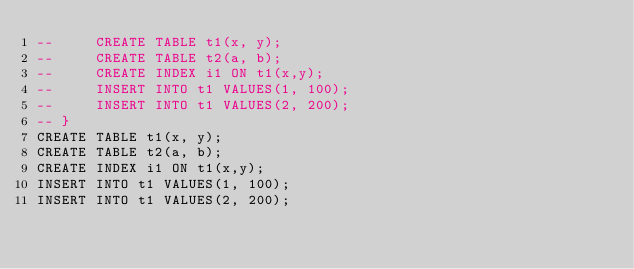<code> <loc_0><loc_0><loc_500><loc_500><_SQL_>--     CREATE TABLE t1(x, y);
--     CREATE TABLE t2(a, b);
--     CREATE INDEX i1 ON t1(x,y);
--     INSERT INTO t1 VALUES(1, 100);
--     INSERT INTO t1 VALUES(2, 200);
-- }
CREATE TABLE t1(x, y);
CREATE TABLE t2(a, b);
CREATE INDEX i1 ON t1(x,y);
INSERT INTO t1 VALUES(1, 100);
INSERT INTO t1 VALUES(2, 200);</code> 